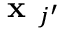<formula> <loc_0><loc_0><loc_500><loc_500>x _ { j ^ { \prime } }</formula> 